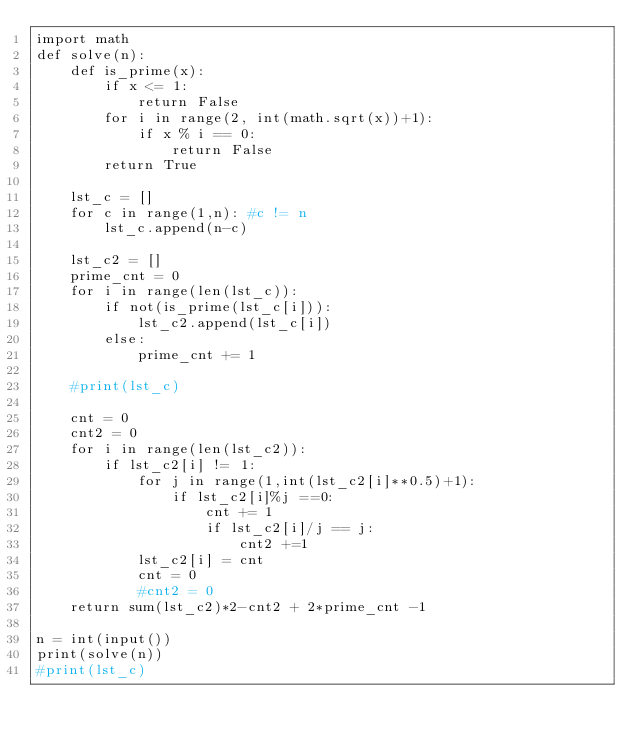Convert code to text. <code><loc_0><loc_0><loc_500><loc_500><_Python_>import math
def solve(n):
    def is_prime(x):
        if x <= 1:
            return False
        for i in range(2, int(math.sqrt(x))+1):
            if x % i == 0:
                return False
        return True

    lst_c = []
    for c in range(1,n): #c != n
        lst_c.append(n-c)

    lst_c2 = []
    prime_cnt = 0
    for i in range(len(lst_c)):
        if not(is_prime(lst_c[i])):
            lst_c2.append(lst_c[i])
        else:
            prime_cnt += 1
            
    #print(lst_c)

    cnt = 0
    cnt2 = 0
    for i in range(len(lst_c2)):
        if lst_c2[i] != 1:
            for j in range(1,int(lst_c2[i]**0.5)+1):
                if lst_c2[i]%j ==0:
                    cnt += 1
                    if lst_c2[i]/j == j:
                        cnt2 +=1
            lst_c2[i] = cnt
            cnt = 0
            #cnt2 = 0
    return sum(lst_c2)*2-cnt2 + 2*prime_cnt -1
    
n = int(input())
print(solve(n))
#print(lst_c)</code> 